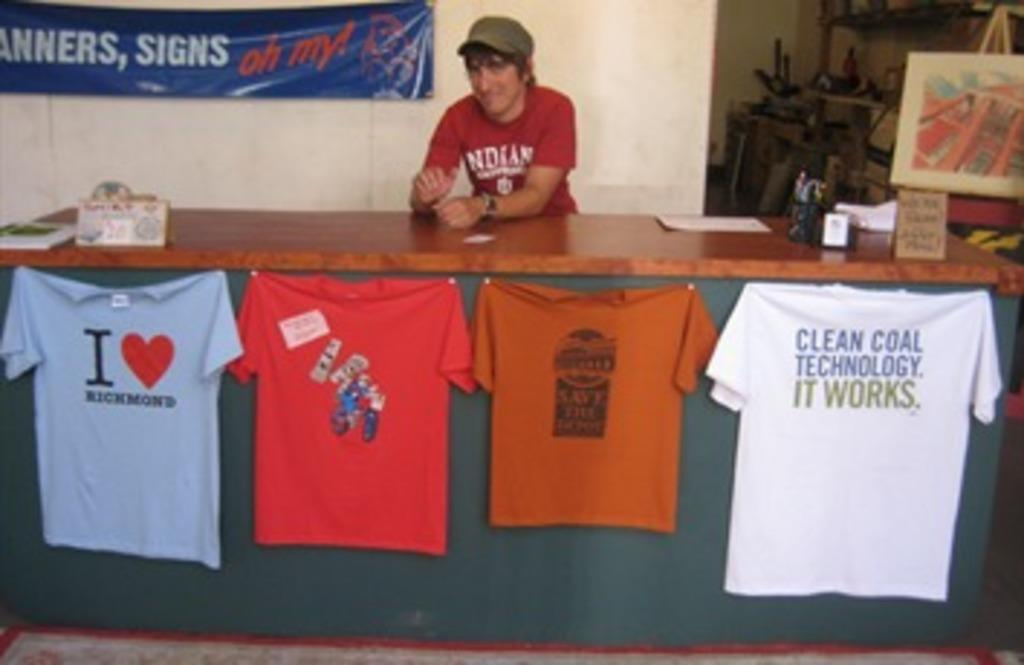What is the man in the image doing? The man is standing in the image. What object can be seen in the image besides the man? There is a table in the image. What is on the table in the image? T-shirts are hanging on the table. What is on the man's back in the image? There is a banner on the man's back. How many brothers does the man have, and what color are their shoes in the image? There is no information about the man's brothers or their shoes in the image. What type of sponge is being used to clean the table in the image? There is no sponge or cleaning activity visible in the image. 